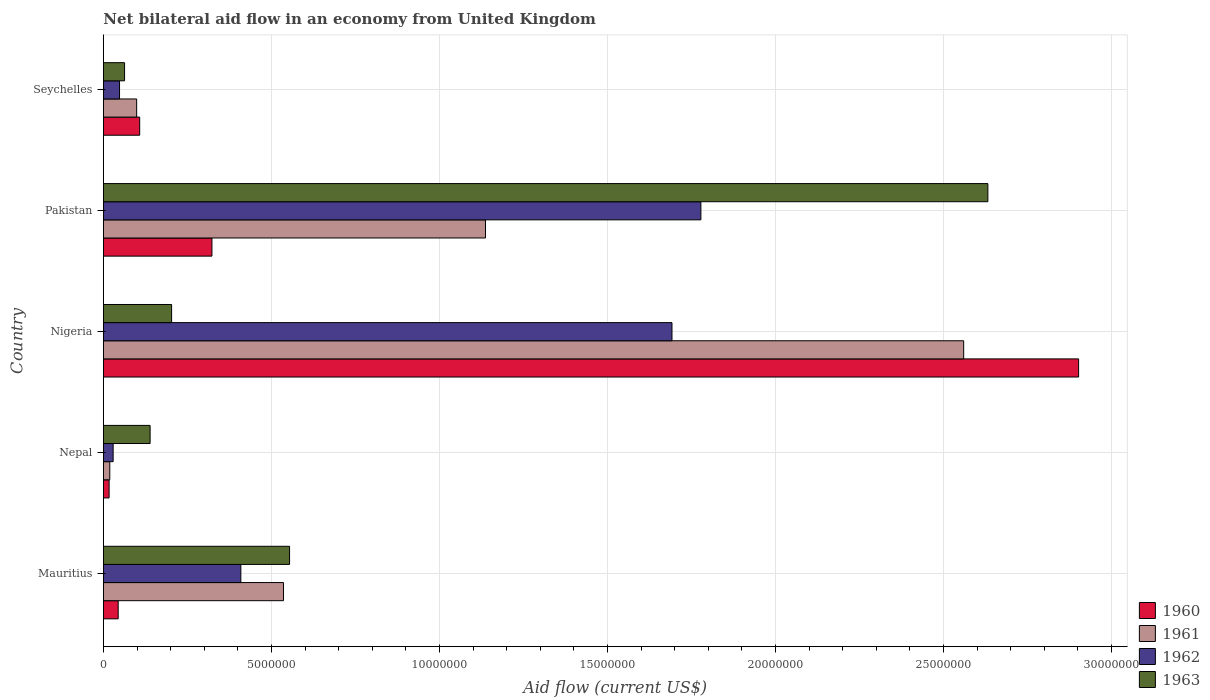How many different coloured bars are there?
Ensure brevity in your answer.  4. How many groups of bars are there?
Offer a terse response. 5. Are the number of bars per tick equal to the number of legend labels?
Ensure brevity in your answer.  Yes. Are the number of bars on each tick of the Y-axis equal?
Provide a short and direct response. Yes. How many bars are there on the 5th tick from the top?
Provide a succinct answer. 4. How many bars are there on the 1st tick from the bottom?
Provide a succinct answer. 4. What is the label of the 3rd group of bars from the top?
Your answer should be very brief. Nigeria. What is the net bilateral aid flow in 1963 in Seychelles?
Provide a succinct answer. 6.30e+05. Across all countries, what is the maximum net bilateral aid flow in 1963?
Offer a terse response. 2.63e+07. In which country was the net bilateral aid flow in 1960 maximum?
Your answer should be compact. Nigeria. In which country was the net bilateral aid flow in 1962 minimum?
Offer a very short reply. Nepal. What is the total net bilateral aid flow in 1963 in the graph?
Ensure brevity in your answer.  3.59e+07. What is the difference between the net bilateral aid flow in 1960 in Nepal and that in Nigeria?
Offer a very short reply. -2.88e+07. What is the difference between the net bilateral aid flow in 1963 in Seychelles and the net bilateral aid flow in 1960 in Mauritius?
Your response must be concise. 1.90e+05. What is the average net bilateral aid flow in 1963 per country?
Provide a short and direct response. 7.18e+06. What is the difference between the net bilateral aid flow in 1961 and net bilateral aid flow in 1963 in Nigeria?
Your response must be concise. 2.36e+07. What is the ratio of the net bilateral aid flow in 1961 in Nigeria to that in Pakistan?
Give a very brief answer. 2.25. Is the net bilateral aid flow in 1961 in Nepal less than that in Pakistan?
Ensure brevity in your answer.  Yes. Is the difference between the net bilateral aid flow in 1961 in Nigeria and Pakistan greater than the difference between the net bilateral aid flow in 1963 in Nigeria and Pakistan?
Your answer should be very brief. Yes. What is the difference between the highest and the second highest net bilateral aid flow in 1960?
Your answer should be very brief. 2.58e+07. What is the difference between the highest and the lowest net bilateral aid flow in 1963?
Give a very brief answer. 2.57e+07. Is the sum of the net bilateral aid flow in 1963 in Pakistan and Seychelles greater than the maximum net bilateral aid flow in 1960 across all countries?
Make the answer very short. No. Is it the case that in every country, the sum of the net bilateral aid flow in 1961 and net bilateral aid flow in 1963 is greater than the sum of net bilateral aid flow in 1960 and net bilateral aid flow in 1962?
Offer a terse response. No. What does the 2nd bar from the bottom in Pakistan represents?
Your response must be concise. 1961. Is it the case that in every country, the sum of the net bilateral aid flow in 1962 and net bilateral aid flow in 1961 is greater than the net bilateral aid flow in 1960?
Keep it short and to the point. Yes. How many bars are there?
Provide a short and direct response. 20. How many countries are there in the graph?
Your answer should be compact. 5. What is the difference between two consecutive major ticks on the X-axis?
Your answer should be compact. 5.00e+06. Are the values on the major ticks of X-axis written in scientific E-notation?
Make the answer very short. No. Where does the legend appear in the graph?
Your response must be concise. Bottom right. What is the title of the graph?
Your answer should be very brief. Net bilateral aid flow in an economy from United Kingdom. Does "2001" appear as one of the legend labels in the graph?
Offer a very short reply. No. What is the Aid flow (current US$) of 1960 in Mauritius?
Offer a terse response. 4.40e+05. What is the Aid flow (current US$) in 1961 in Mauritius?
Offer a terse response. 5.36e+06. What is the Aid flow (current US$) in 1962 in Mauritius?
Your response must be concise. 4.09e+06. What is the Aid flow (current US$) in 1963 in Mauritius?
Provide a succinct answer. 5.54e+06. What is the Aid flow (current US$) of 1961 in Nepal?
Keep it short and to the point. 1.90e+05. What is the Aid flow (current US$) in 1962 in Nepal?
Your answer should be very brief. 2.90e+05. What is the Aid flow (current US$) of 1963 in Nepal?
Your answer should be very brief. 1.39e+06. What is the Aid flow (current US$) in 1960 in Nigeria?
Ensure brevity in your answer.  2.90e+07. What is the Aid flow (current US$) in 1961 in Nigeria?
Your answer should be very brief. 2.56e+07. What is the Aid flow (current US$) of 1962 in Nigeria?
Make the answer very short. 1.69e+07. What is the Aid flow (current US$) in 1963 in Nigeria?
Provide a short and direct response. 2.03e+06. What is the Aid flow (current US$) in 1960 in Pakistan?
Provide a succinct answer. 3.23e+06. What is the Aid flow (current US$) of 1961 in Pakistan?
Your answer should be compact. 1.14e+07. What is the Aid flow (current US$) in 1962 in Pakistan?
Your answer should be very brief. 1.78e+07. What is the Aid flow (current US$) in 1963 in Pakistan?
Ensure brevity in your answer.  2.63e+07. What is the Aid flow (current US$) of 1960 in Seychelles?
Provide a short and direct response. 1.08e+06. What is the Aid flow (current US$) in 1961 in Seychelles?
Ensure brevity in your answer.  9.90e+05. What is the Aid flow (current US$) of 1962 in Seychelles?
Your response must be concise. 4.80e+05. What is the Aid flow (current US$) of 1963 in Seychelles?
Offer a very short reply. 6.30e+05. Across all countries, what is the maximum Aid flow (current US$) in 1960?
Make the answer very short. 2.90e+07. Across all countries, what is the maximum Aid flow (current US$) in 1961?
Make the answer very short. 2.56e+07. Across all countries, what is the maximum Aid flow (current US$) of 1962?
Offer a very short reply. 1.78e+07. Across all countries, what is the maximum Aid flow (current US$) of 1963?
Ensure brevity in your answer.  2.63e+07. Across all countries, what is the minimum Aid flow (current US$) in 1961?
Your response must be concise. 1.90e+05. Across all countries, what is the minimum Aid flow (current US$) of 1962?
Your answer should be very brief. 2.90e+05. Across all countries, what is the minimum Aid flow (current US$) of 1963?
Ensure brevity in your answer.  6.30e+05. What is the total Aid flow (current US$) of 1960 in the graph?
Offer a very short reply. 3.39e+07. What is the total Aid flow (current US$) of 1961 in the graph?
Provide a short and direct response. 4.35e+07. What is the total Aid flow (current US$) in 1962 in the graph?
Your answer should be compact. 3.96e+07. What is the total Aid flow (current US$) in 1963 in the graph?
Your response must be concise. 3.59e+07. What is the difference between the Aid flow (current US$) in 1961 in Mauritius and that in Nepal?
Your response must be concise. 5.17e+06. What is the difference between the Aid flow (current US$) in 1962 in Mauritius and that in Nepal?
Make the answer very short. 3.80e+06. What is the difference between the Aid flow (current US$) of 1963 in Mauritius and that in Nepal?
Your response must be concise. 4.15e+06. What is the difference between the Aid flow (current US$) in 1960 in Mauritius and that in Nigeria?
Provide a short and direct response. -2.86e+07. What is the difference between the Aid flow (current US$) in 1961 in Mauritius and that in Nigeria?
Your answer should be compact. -2.02e+07. What is the difference between the Aid flow (current US$) of 1962 in Mauritius and that in Nigeria?
Offer a very short reply. -1.28e+07. What is the difference between the Aid flow (current US$) of 1963 in Mauritius and that in Nigeria?
Keep it short and to the point. 3.51e+06. What is the difference between the Aid flow (current US$) of 1960 in Mauritius and that in Pakistan?
Offer a very short reply. -2.79e+06. What is the difference between the Aid flow (current US$) of 1961 in Mauritius and that in Pakistan?
Offer a very short reply. -6.01e+06. What is the difference between the Aid flow (current US$) of 1962 in Mauritius and that in Pakistan?
Your answer should be compact. -1.37e+07. What is the difference between the Aid flow (current US$) of 1963 in Mauritius and that in Pakistan?
Make the answer very short. -2.08e+07. What is the difference between the Aid flow (current US$) in 1960 in Mauritius and that in Seychelles?
Provide a succinct answer. -6.40e+05. What is the difference between the Aid flow (current US$) in 1961 in Mauritius and that in Seychelles?
Make the answer very short. 4.37e+06. What is the difference between the Aid flow (current US$) of 1962 in Mauritius and that in Seychelles?
Keep it short and to the point. 3.61e+06. What is the difference between the Aid flow (current US$) in 1963 in Mauritius and that in Seychelles?
Your response must be concise. 4.91e+06. What is the difference between the Aid flow (current US$) of 1960 in Nepal and that in Nigeria?
Ensure brevity in your answer.  -2.88e+07. What is the difference between the Aid flow (current US$) in 1961 in Nepal and that in Nigeria?
Provide a succinct answer. -2.54e+07. What is the difference between the Aid flow (current US$) in 1962 in Nepal and that in Nigeria?
Ensure brevity in your answer.  -1.66e+07. What is the difference between the Aid flow (current US$) in 1963 in Nepal and that in Nigeria?
Provide a short and direct response. -6.40e+05. What is the difference between the Aid flow (current US$) in 1960 in Nepal and that in Pakistan?
Offer a terse response. -3.06e+06. What is the difference between the Aid flow (current US$) in 1961 in Nepal and that in Pakistan?
Make the answer very short. -1.12e+07. What is the difference between the Aid flow (current US$) in 1962 in Nepal and that in Pakistan?
Your answer should be compact. -1.75e+07. What is the difference between the Aid flow (current US$) of 1963 in Nepal and that in Pakistan?
Provide a short and direct response. -2.49e+07. What is the difference between the Aid flow (current US$) of 1960 in Nepal and that in Seychelles?
Your response must be concise. -9.10e+05. What is the difference between the Aid flow (current US$) of 1961 in Nepal and that in Seychelles?
Offer a very short reply. -8.00e+05. What is the difference between the Aid flow (current US$) in 1963 in Nepal and that in Seychelles?
Give a very brief answer. 7.60e+05. What is the difference between the Aid flow (current US$) of 1960 in Nigeria and that in Pakistan?
Keep it short and to the point. 2.58e+07. What is the difference between the Aid flow (current US$) of 1961 in Nigeria and that in Pakistan?
Make the answer very short. 1.42e+07. What is the difference between the Aid flow (current US$) in 1962 in Nigeria and that in Pakistan?
Your answer should be very brief. -8.60e+05. What is the difference between the Aid flow (current US$) in 1963 in Nigeria and that in Pakistan?
Provide a succinct answer. -2.43e+07. What is the difference between the Aid flow (current US$) in 1960 in Nigeria and that in Seychelles?
Provide a short and direct response. 2.79e+07. What is the difference between the Aid flow (current US$) of 1961 in Nigeria and that in Seychelles?
Your response must be concise. 2.46e+07. What is the difference between the Aid flow (current US$) in 1962 in Nigeria and that in Seychelles?
Offer a very short reply. 1.64e+07. What is the difference between the Aid flow (current US$) of 1963 in Nigeria and that in Seychelles?
Ensure brevity in your answer.  1.40e+06. What is the difference between the Aid flow (current US$) in 1960 in Pakistan and that in Seychelles?
Your answer should be compact. 2.15e+06. What is the difference between the Aid flow (current US$) in 1961 in Pakistan and that in Seychelles?
Provide a succinct answer. 1.04e+07. What is the difference between the Aid flow (current US$) of 1962 in Pakistan and that in Seychelles?
Ensure brevity in your answer.  1.73e+07. What is the difference between the Aid flow (current US$) of 1963 in Pakistan and that in Seychelles?
Your response must be concise. 2.57e+07. What is the difference between the Aid flow (current US$) of 1960 in Mauritius and the Aid flow (current US$) of 1961 in Nepal?
Offer a very short reply. 2.50e+05. What is the difference between the Aid flow (current US$) in 1960 in Mauritius and the Aid flow (current US$) in 1963 in Nepal?
Give a very brief answer. -9.50e+05. What is the difference between the Aid flow (current US$) of 1961 in Mauritius and the Aid flow (current US$) of 1962 in Nepal?
Ensure brevity in your answer.  5.07e+06. What is the difference between the Aid flow (current US$) in 1961 in Mauritius and the Aid flow (current US$) in 1963 in Nepal?
Provide a short and direct response. 3.97e+06. What is the difference between the Aid flow (current US$) in 1962 in Mauritius and the Aid flow (current US$) in 1963 in Nepal?
Your answer should be compact. 2.70e+06. What is the difference between the Aid flow (current US$) of 1960 in Mauritius and the Aid flow (current US$) of 1961 in Nigeria?
Provide a succinct answer. -2.52e+07. What is the difference between the Aid flow (current US$) in 1960 in Mauritius and the Aid flow (current US$) in 1962 in Nigeria?
Your answer should be very brief. -1.65e+07. What is the difference between the Aid flow (current US$) in 1960 in Mauritius and the Aid flow (current US$) in 1963 in Nigeria?
Offer a very short reply. -1.59e+06. What is the difference between the Aid flow (current US$) of 1961 in Mauritius and the Aid flow (current US$) of 1962 in Nigeria?
Keep it short and to the point. -1.16e+07. What is the difference between the Aid flow (current US$) of 1961 in Mauritius and the Aid flow (current US$) of 1963 in Nigeria?
Provide a succinct answer. 3.33e+06. What is the difference between the Aid flow (current US$) of 1962 in Mauritius and the Aid flow (current US$) of 1963 in Nigeria?
Your answer should be very brief. 2.06e+06. What is the difference between the Aid flow (current US$) of 1960 in Mauritius and the Aid flow (current US$) of 1961 in Pakistan?
Offer a very short reply. -1.09e+07. What is the difference between the Aid flow (current US$) in 1960 in Mauritius and the Aid flow (current US$) in 1962 in Pakistan?
Your response must be concise. -1.73e+07. What is the difference between the Aid flow (current US$) in 1960 in Mauritius and the Aid flow (current US$) in 1963 in Pakistan?
Offer a terse response. -2.59e+07. What is the difference between the Aid flow (current US$) of 1961 in Mauritius and the Aid flow (current US$) of 1962 in Pakistan?
Your answer should be compact. -1.24e+07. What is the difference between the Aid flow (current US$) of 1961 in Mauritius and the Aid flow (current US$) of 1963 in Pakistan?
Keep it short and to the point. -2.10e+07. What is the difference between the Aid flow (current US$) of 1962 in Mauritius and the Aid flow (current US$) of 1963 in Pakistan?
Your answer should be compact. -2.22e+07. What is the difference between the Aid flow (current US$) of 1960 in Mauritius and the Aid flow (current US$) of 1961 in Seychelles?
Provide a succinct answer. -5.50e+05. What is the difference between the Aid flow (current US$) in 1960 in Mauritius and the Aid flow (current US$) in 1963 in Seychelles?
Offer a terse response. -1.90e+05. What is the difference between the Aid flow (current US$) in 1961 in Mauritius and the Aid flow (current US$) in 1962 in Seychelles?
Offer a very short reply. 4.88e+06. What is the difference between the Aid flow (current US$) in 1961 in Mauritius and the Aid flow (current US$) in 1963 in Seychelles?
Your answer should be compact. 4.73e+06. What is the difference between the Aid flow (current US$) of 1962 in Mauritius and the Aid flow (current US$) of 1963 in Seychelles?
Make the answer very short. 3.46e+06. What is the difference between the Aid flow (current US$) in 1960 in Nepal and the Aid flow (current US$) in 1961 in Nigeria?
Give a very brief answer. -2.54e+07. What is the difference between the Aid flow (current US$) of 1960 in Nepal and the Aid flow (current US$) of 1962 in Nigeria?
Keep it short and to the point. -1.68e+07. What is the difference between the Aid flow (current US$) of 1960 in Nepal and the Aid flow (current US$) of 1963 in Nigeria?
Offer a terse response. -1.86e+06. What is the difference between the Aid flow (current US$) of 1961 in Nepal and the Aid flow (current US$) of 1962 in Nigeria?
Your response must be concise. -1.67e+07. What is the difference between the Aid flow (current US$) in 1961 in Nepal and the Aid flow (current US$) in 1963 in Nigeria?
Offer a very short reply. -1.84e+06. What is the difference between the Aid flow (current US$) of 1962 in Nepal and the Aid flow (current US$) of 1963 in Nigeria?
Provide a succinct answer. -1.74e+06. What is the difference between the Aid flow (current US$) of 1960 in Nepal and the Aid flow (current US$) of 1961 in Pakistan?
Offer a very short reply. -1.12e+07. What is the difference between the Aid flow (current US$) of 1960 in Nepal and the Aid flow (current US$) of 1962 in Pakistan?
Make the answer very short. -1.76e+07. What is the difference between the Aid flow (current US$) of 1960 in Nepal and the Aid flow (current US$) of 1963 in Pakistan?
Offer a very short reply. -2.62e+07. What is the difference between the Aid flow (current US$) in 1961 in Nepal and the Aid flow (current US$) in 1962 in Pakistan?
Provide a short and direct response. -1.76e+07. What is the difference between the Aid flow (current US$) in 1961 in Nepal and the Aid flow (current US$) in 1963 in Pakistan?
Your answer should be compact. -2.61e+07. What is the difference between the Aid flow (current US$) in 1962 in Nepal and the Aid flow (current US$) in 1963 in Pakistan?
Your response must be concise. -2.60e+07. What is the difference between the Aid flow (current US$) in 1960 in Nepal and the Aid flow (current US$) in 1961 in Seychelles?
Provide a short and direct response. -8.20e+05. What is the difference between the Aid flow (current US$) of 1960 in Nepal and the Aid flow (current US$) of 1962 in Seychelles?
Your response must be concise. -3.10e+05. What is the difference between the Aid flow (current US$) in 1960 in Nepal and the Aid flow (current US$) in 1963 in Seychelles?
Your answer should be very brief. -4.60e+05. What is the difference between the Aid flow (current US$) of 1961 in Nepal and the Aid flow (current US$) of 1963 in Seychelles?
Provide a succinct answer. -4.40e+05. What is the difference between the Aid flow (current US$) in 1962 in Nepal and the Aid flow (current US$) in 1963 in Seychelles?
Your answer should be compact. -3.40e+05. What is the difference between the Aid flow (current US$) in 1960 in Nigeria and the Aid flow (current US$) in 1961 in Pakistan?
Give a very brief answer. 1.76e+07. What is the difference between the Aid flow (current US$) in 1960 in Nigeria and the Aid flow (current US$) in 1962 in Pakistan?
Keep it short and to the point. 1.12e+07. What is the difference between the Aid flow (current US$) in 1960 in Nigeria and the Aid flow (current US$) in 1963 in Pakistan?
Ensure brevity in your answer.  2.70e+06. What is the difference between the Aid flow (current US$) of 1961 in Nigeria and the Aid flow (current US$) of 1962 in Pakistan?
Give a very brief answer. 7.82e+06. What is the difference between the Aid flow (current US$) in 1961 in Nigeria and the Aid flow (current US$) in 1963 in Pakistan?
Your response must be concise. -7.20e+05. What is the difference between the Aid flow (current US$) of 1962 in Nigeria and the Aid flow (current US$) of 1963 in Pakistan?
Provide a short and direct response. -9.40e+06. What is the difference between the Aid flow (current US$) in 1960 in Nigeria and the Aid flow (current US$) in 1961 in Seychelles?
Provide a succinct answer. 2.80e+07. What is the difference between the Aid flow (current US$) of 1960 in Nigeria and the Aid flow (current US$) of 1962 in Seychelles?
Your response must be concise. 2.85e+07. What is the difference between the Aid flow (current US$) in 1960 in Nigeria and the Aid flow (current US$) in 1963 in Seychelles?
Your answer should be very brief. 2.84e+07. What is the difference between the Aid flow (current US$) of 1961 in Nigeria and the Aid flow (current US$) of 1962 in Seychelles?
Your answer should be compact. 2.51e+07. What is the difference between the Aid flow (current US$) of 1961 in Nigeria and the Aid flow (current US$) of 1963 in Seychelles?
Make the answer very short. 2.50e+07. What is the difference between the Aid flow (current US$) in 1962 in Nigeria and the Aid flow (current US$) in 1963 in Seychelles?
Your answer should be compact. 1.63e+07. What is the difference between the Aid flow (current US$) of 1960 in Pakistan and the Aid flow (current US$) of 1961 in Seychelles?
Your answer should be very brief. 2.24e+06. What is the difference between the Aid flow (current US$) of 1960 in Pakistan and the Aid flow (current US$) of 1962 in Seychelles?
Provide a succinct answer. 2.75e+06. What is the difference between the Aid flow (current US$) in 1960 in Pakistan and the Aid flow (current US$) in 1963 in Seychelles?
Your answer should be very brief. 2.60e+06. What is the difference between the Aid flow (current US$) in 1961 in Pakistan and the Aid flow (current US$) in 1962 in Seychelles?
Provide a short and direct response. 1.09e+07. What is the difference between the Aid flow (current US$) in 1961 in Pakistan and the Aid flow (current US$) in 1963 in Seychelles?
Keep it short and to the point. 1.07e+07. What is the difference between the Aid flow (current US$) of 1962 in Pakistan and the Aid flow (current US$) of 1963 in Seychelles?
Offer a very short reply. 1.72e+07. What is the average Aid flow (current US$) in 1960 per country?
Provide a short and direct response. 6.79e+06. What is the average Aid flow (current US$) in 1961 per country?
Your answer should be very brief. 8.70e+06. What is the average Aid flow (current US$) of 1962 per country?
Provide a short and direct response. 7.91e+06. What is the average Aid flow (current US$) of 1963 per country?
Your answer should be very brief. 7.18e+06. What is the difference between the Aid flow (current US$) of 1960 and Aid flow (current US$) of 1961 in Mauritius?
Keep it short and to the point. -4.92e+06. What is the difference between the Aid flow (current US$) of 1960 and Aid flow (current US$) of 1962 in Mauritius?
Provide a short and direct response. -3.65e+06. What is the difference between the Aid flow (current US$) of 1960 and Aid flow (current US$) of 1963 in Mauritius?
Ensure brevity in your answer.  -5.10e+06. What is the difference between the Aid flow (current US$) in 1961 and Aid flow (current US$) in 1962 in Mauritius?
Ensure brevity in your answer.  1.27e+06. What is the difference between the Aid flow (current US$) of 1962 and Aid flow (current US$) of 1963 in Mauritius?
Ensure brevity in your answer.  -1.45e+06. What is the difference between the Aid flow (current US$) in 1960 and Aid flow (current US$) in 1961 in Nepal?
Offer a terse response. -2.00e+04. What is the difference between the Aid flow (current US$) of 1960 and Aid flow (current US$) of 1963 in Nepal?
Provide a succinct answer. -1.22e+06. What is the difference between the Aid flow (current US$) of 1961 and Aid flow (current US$) of 1962 in Nepal?
Offer a terse response. -1.00e+05. What is the difference between the Aid flow (current US$) in 1961 and Aid flow (current US$) in 1963 in Nepal?
Give a very brief answer. -1.20e+06. What is the difference between the Aid flow (current US$) of 1962 and Aid flow (current US$) of 1963 in Nepal?
Your answer should be compact. -1.10e+06. What is the difference between the Aid flow (current US$) in 1960 and Aid flow (current US$) in 1961 in Nigeria?
Your response must be concise. 3.42e+06. What is the difference between the Aid flow (current US$) of 1960 and Aid flow (current US$) of 1962 in Nigeria?
Provide a succinct answer. 1.21e+07. What is the difference between the Aid flow (current US$) in 1960 and Aid flow (current US$) in 1963 in Nigeria?
Make the answer very short. 2.70e+07. What is the difference between the Aid flow (current US$) in 1961 and Aid flow (current US$) in 1962 in Nigeria?
Provide a short and direct response. 8.68e+06. What is the difference between the Aid flow (current US$) in 1961 and Aid flow (current US$) in 1963 in Nigeria?
Give a very brief answer. 2.36e+07. What is the difference between the Aid flow (current US$) in 1962 and Aid flow (current US$) in 1963 in Nigeria?
Your answer should be compact. 1.49e+07. What is the difference between the Aid flow (current US$) of 1960 and Aid flow (current US$) of 1961 in Pakistan?
Keep it short and to the point. -8.14e+06. What is the difference between the Aid flow (current US$) of 1960 and Aid flow (current US$) of 1962 in Pakistan?
Keep it short and to the point. -1.46e+07. What is the difference between the Aid flow (current US$) in 1960 and Aid flow (current US$) in 1963 in Pakistan?
Provide a short and direct response. -2.31e+07. What is the difference between the Aid flow (current US$) of 1961 and Aid flow (current US$) of 1962 in Pakistan?
Your response must be concise. -6.41e+06. What is the difference between the Aid flow (current US$) of 1961 and Aid flow (current US$) of 1963 in Pakistan?
Your response must be concise. -1.50e+07. What is the difference between the Aid flow (current US$) of 1962 and Aid flow (current US$) of 1963 in Pakistan?
Your answer should be compact. -8.54e+06. What is the difference between the Aid flow (current US$) in 1960 and Aid flow (current US$) in 1961 in Seychelles?
Ensure brevity in your answer.  9.00e+04. What is the difference between the Aid flow (current US$) in 1960 and Aid flow (current US$) in 1962 in Seychelles?
Offer a very short reply. 6.00e+05. What is the difference between the Aid flow (current US$) in 1960 and Aid flow (current US$) in 1963 in Seychelles?
Make the answer very short. 4.50e+05. What is the difference between the Aid flow (current US$) of 1961 and Aid flow (current US$) of 1962 in Seychelles?
Ensure brevity in your answer.  5.10e+05. What is the difference between the Aid flow (current US$) of 1962 and Aid flow (current US$) of 1963 in Seychelles?
Keep it short and to the point. -1.50e+05. What is the ratio of the Aid flow (current US$) of 1960 in Mauritius to that in Nepal?
Provide a short and direct response. 2.59. What is the ratio of the Aid flow (current US$) of 1961 in Mauritius to that in Nepal?
Ensure brevity in your answer.  28.21. What is the ratio of the Aid flow (current US$) in 1962 in Mauritius to that in Nepal?
Offer a very short reply. 14.1. What is the ratio of the Aid flow (current US$) of 1963 in Mauritius to that in Nepal?
Keep it short and to the point. 3.99. What is the ratio of the Aid flow (current US$) of 1960 in Mauritius to that in Nigeria?
Keep it short and to the point. 0.02. What is the ratio of the Aid flow (current US$) in 1961 in Mauritius to that in Nigeria?
Provide a short and direct response. 0.21. What is the ratio of the Aid flow (current US$) of 1962 in Mauritius to that in Nigeria?
Offer a terse response. 0.24. What is the ratio of the Aid flow (current US$) of 1963 in Mauritius to that in Nigeria?
Your answer should be very brief. 2.73. What is the ratio of the Aid flow (current US$) in 1960 in Mauritius to that in Pakistan?
Make the answer very short. 0.14. What is the ratio of the Aid flow (current US$) of 1961 in Mauritius to that in Pakistan?
Give a very brief answer. 0.47. What is the ratio of the Aid flow (current US$) of 1962 in Mauritius to that in Pakistan?
Offer a very short reply. 0.23. What is the ratio of the Aid flow (current US$) of 1963 in Mauritius to that in Pakistan?
Your answer should be compact. 0.21. What is the ratio of the Aid flow (current US$) in 1960 in Mauritius to that in Seychelles?
Your response must be concise. 0.41. What is the ratio of the Aid flow (current US$) of 1961 in Mauritius to that in Seychelles?
Provide a succinct answer. 5.41. What is the ratio of the Aid flow (current US$) of 1962 in Mauritius to that in Seychelles?
Offer a very short reply. 8.52. What is the ratio of the Aid flow (current US$) in 1963 in Mauritius to that in Seychelles?
Ensure brevity in your answer.  8.79. What is the ratio of the Aid flow (current US$) of 1960 in Nepal to that in Nigeria?
Your response must be concise. 0.01. What is the ratio of the Aid flow (current US$) in 1961 in Nepal to that in Nigeria?
Offer a terse response. 0.01. What is the ratio of the Aid flow (current US$) in 1962 in Nepal to that in Nigeria?
Offer a very short reply. 0.02. What is the ratio of the Aid flow (current US$) of 1963 in Nepal to that in Nigeria?
Provide a short and direct response. 0.68. What is the ratio of the Aid flow (current US$) in 1960 in Nepal to that in Pakistan?
Ensure brevity in your answer.  0.05. What is the ratio of the Aid flow (current US$) of 1961 in Nepal to that in Pakistan?
Offer a very short reply. 0.02. What is the ratio of the Aid flow (current US$) of 1962 in Nepal to that in Pakistan?
Offer a terse response. 0.02. What is the ratio of the Aid flow (current US$) of 1963 in Nepal to that in Pakistan?
Offer a very short reply. 0.05. What is the ratio of the Aid flow (current US$) in 1960 in Nepal to that in Seychelles?
Your answer should be compact. 0.16. What is the ratio of the Aid flow (current US$) of 1961 in Nepal to that in Seychelles?
Offer a terse response. 0.19. What is the ratio of the Aid flow (current US$) in 1962 in Nepal to that in Seychelles?
Provide a short and direct response. 0.6. What is the ratio of the Aid flow (current US$) of 1963 in Nepal to that in Seychelles?
Keep it short and to the point. 2.21. What is the ratio of the Aid flow (current US$) in 1960 in Nigeria to that in Pakistan?
Ensure brevity in your answer.  8.98. What is the ratio of the Aid flow (current US$) of 1961 in Nigeria to that in Pakistan?
Provide a short and direct response. 2.25. What is the ratio of the Aid flow (current US$) of 1962 in Nigeria to that in Pakistan?
Provide a succinct answer. 0.95. What is the ratio of the Aid flow (current US$) in 1963 in Nigeria to that in Pakistan?
Provide a succinct answer. 0.08. What is the ratio of the Aid flow (current US$) in 1960 in Nigeria to that in Seychelles?
Offer a terse response. 26.87. What is the ratio of the Aid flow (current US$) of 1961 in Nigeria to that in Seychelles?
Keep it short and to the point. 25.86. What is the ratio of the Aid flow (current US$) in 1962 in Nigeria to that in Seychelles?
Your answer should be compact. 35.25. What is the ratio of the Aid flow (current US$) in 1963 in Nigeria to that in Seychelles?
Your answer should be very brief. 3.22. What is the ratio of the Aid flow (current US$) in 1960 in Pakistan to that in Seychelles?
Your answer should be compact. 2.99. What is the ratio of the Aid flow (current US$) of 1961 in Pakistan to that in Seychelles?
Make the answer very short. 11.48. What is the ratio of the Aid flow (current US$) of 1962 in Pakistan to that in Seychelles?
Ensure brevity in your answer.  37.04. What is the ratio of the Aid flow (current US$) in 1963 in Pakistan to that in Seychelles?
Give a very brief answer. 41.78. What is the difference between the highest and the second highest Aid flow (current US$) of 1960?
Your answer should be very brief. 2.58e+07. What is the difference between the highest and the second highest Aid flow (current US$) in 1961?
Make the answer very short. 1.42e+07. What is the difference between the highest and the second highest Aid flow (current US$) of 1962?
Your answer should be very brief. 8.60e+05. What is the difference between the highest and the second highest Aid flow (current US$) of 1963?
Provide a short and direct response. 2.08e+07. What is the difference between the highest and the lowest Aid flow (current US$) in 1960?
Provide a short and direct response. 2.88e+07. What is the difference between the highest and the lowest Aid flow (current US$) of 1961?
Provide a succinct answer. 2.54e+07. What is the difference between the highest and the lowest Aid flow (current US$) in 1962?
Your answer should be compact. 1.75e+07. What is the difference between the highest and the lowest Aid flow (current US$) of 1963?
Provide a succinct answer. 2.57e+07. 